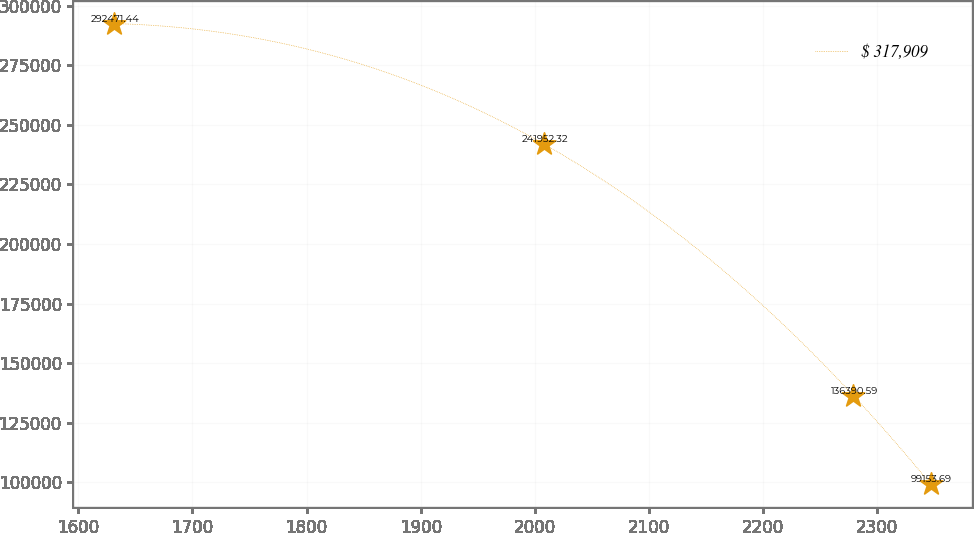Convert chart. <chart><loc_0><loc_0><loc_500><loc_500><line_chart><ecel><fcel>$ 317,909<nl><fcel>1631.55<fcel>292471<nl><fcel>2007.89<fcel>241952<nl><fcel>2279.04<fcel>136391<nl><fcel>2346.85<fcel>99153.7<nl></chart> 